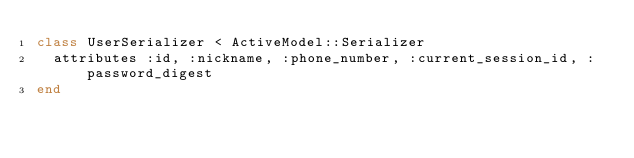Convert code to text. <code><loc_0><loc_0><loc_500><loc_500><_Ruby_>class UserSerializer < ActiveModel::Serializer
  attributes :id, :nickname, :phone_number, :current_session_id, :password_digest
end
</code> 